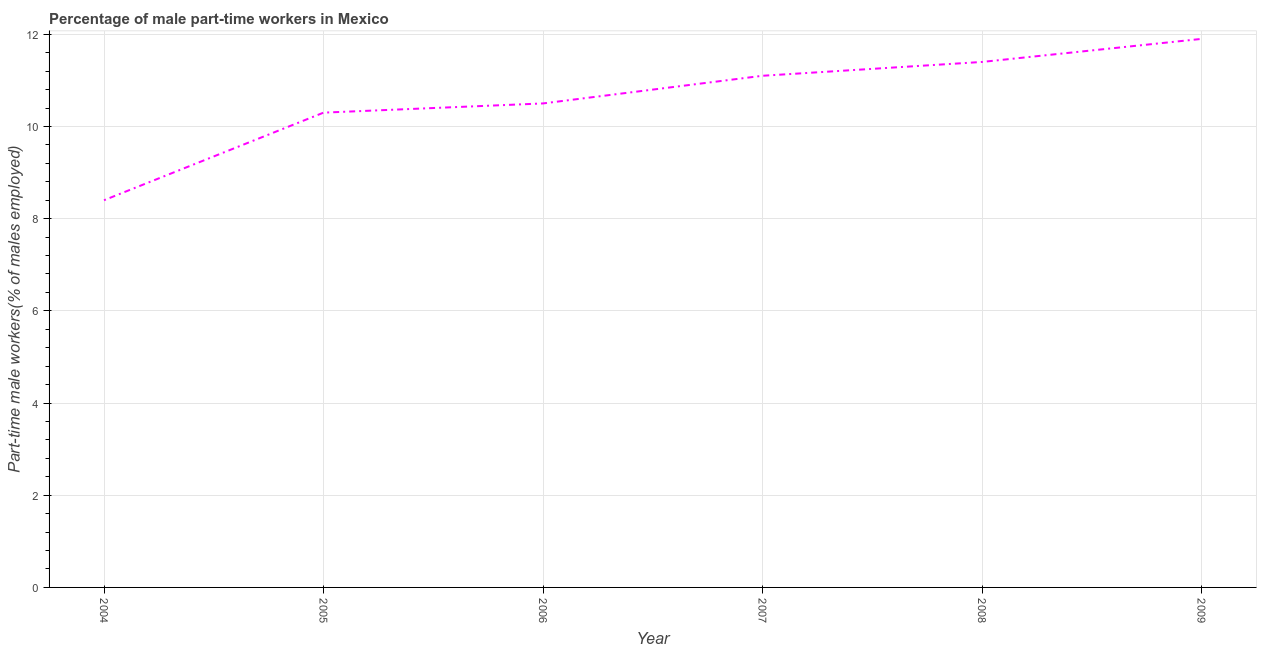What is the percentage of part-time male workers in 2007?
Your answer should be very brief. 11.1. Across all years, what is the maximum percentage of part-time male workers?
Keep it short and to the point. 11.9. Across all years, what is the minimum percentage of part-time male workers?
Your answer should be very brief. 8.4. In which year was the percentage of part-time male workers maximum?
Offer a terse response. 2009. In which year was the percentage of part-time male workers minimum?
Your response must be concise. 2004. What is the sum of the percentage of part-time male workers?
Your response must be concise. 63.6. What is the difference between the percentage of part-time male workers in 2004 and 2008?
Provide a succinct answer. -3. What is the average percentage of part-time male workers per year?
Make the answer very short. 10.6. What is the median percentage of part-time male workers?
Your answer should be compact. 10.8. In how many years, is the percentage of part-time male workers greater than 3.2 %?
Keep it short and to the point. 6. What is the ratio of the percentage of part-time male workers in 2005 to that in 2009?
Your answer should be very brief. 0.87. Is the percentage of part-time male workers in 2007 less than that in 2008?
Provide a short and direct response. Yes. What is the difference between the highest and the lowest percentage of part-time male workers?
Your answer should be compact. 3.5. Does the percentage of part-time male workers monotonically increase over the years?
Keep it short and to the point. Yes. How many lines are there?
Your response must be concise. 1. Are the values on the major ticks of Y-axis written in scientific E-notation?
Your response must be concise. No. Does the graph contain grids?
Your answer should be compact. Yes. What is the title of the graph?
Offer a very short reply. Percentage of male part-time workers in Mexico. What is the label or title of the Y-axis?
Keep it short and to the point. Part-time male workers(% of males employed). What is the Part-time male workers(% of males employed) in 2004?
Your answer should be very brief. 8.4. What is the Part-time male workers(% of males employed) of 2005?
Ensure brevity in your answer.  10.3. What is the Part-time male workers(% of males employed) in 2006?
Your response must be concise. 10.5. What is the Part-time male workers(% of males employed) in 2007?
Keep it short and to the point. 11.1. What is the Part-time male workers(% of males employed) of 2008?
Offer a terse response. 11.4. What is the Part-time male workers(% of males employed) in 2009?
Give a very brief answer. 11.9. What is the difference between the Part-time male workers(% of males employed) in 2004 and 2006?
Provide a short and direct response. -2.1. What is the difference between the Part-time male workers(% of males employed) in 2004 and 2007?
Keep it short and to the point. -2.7. What is the difference between the Part-time male workers(% of males employed) in 2004 and 2008?
Offer a terse response. -3. What is the difference between the Part-time male workers(% of males employed) in 2005 and 2006?
Offer a terse response. -0.2. What is the difference between the Part-time male workers(% of males employed) in 2005 and 2008?
Give a very brief answer. -1.1. What is the difference between the Part-time male workers(% of males employed) in 2006 and 2008?
Give a very brief answer. -0.9. What is the ratio of the Part-time male workers(% of males employed) in 2004 to that in 2005?
Keep it short and to the point. 0.82. What is the ratio of the Part-time male workers(% of males employed) in 2004 to that in 2007?
Make the answer very short. 0.76. What is the ratio of the Part-time male workers(% of males employed) in 2004 to that in 2008?
Provide a short and direct response. 0.74. What is the ratio of the Part-time male workers(% of males employed) in 2004 to that in 2009?
Your answer should be compact. 0.71. What is the ratio of the Part-time male workers(% of males employed) in 2005 to that in 2007?
Offer a terse response. 0.93. What is the ratio of the Part-time male workers(% of males employed) in 2005 to that in 2008?
Make the answer very short. 0.9. What is the ratio of the Part-time male workers(% of males employed) in 2005 to that in 2009?
Your answer should be very brief. 0.87. What is the ratio of the Part-time male workers(% of males employed) in 2006 to that in 2007?
Give a very brief answer. 0.95. What is the ratio of the Part-time male workers(% of males employed) in 2006 to that in 2008?
Your answer should be compact. 0.92. What is the ratio of the Part-time male workers(% of males employed) in 2006 to that in 2009?
Keep it short and to the point. 0.88. What is the ratio of the Part-time male workers(% of males employed) in 2007 to that in 2008?
Your response must be concise. 0.97. What is the ratio of the Part-time male workers(% of males employed) in 2007 to that in 2009?
Make the answer very short. 0.93. What is the ratio of the Part-time male workers(% of males employed) in 2008 to that in 2009?
Make the answer very short. 0.96. 